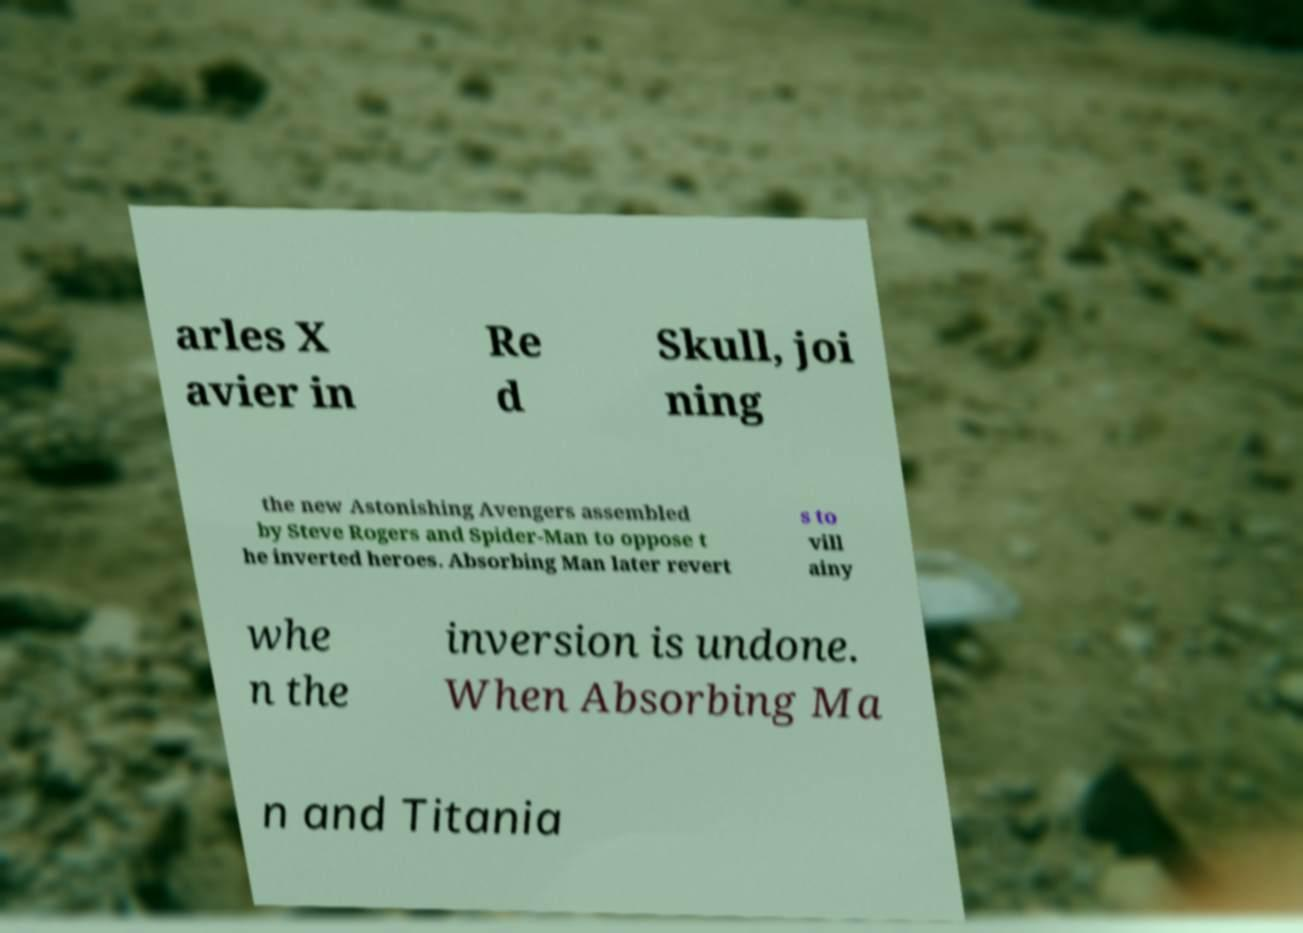Could you assist in decoding the text presented in this image and type it out clearly? arles X avier in Re d Skull, joi ning the new Astonishing Avengers assembled by Steve Rogers and Spider-Man to oppose t he inverted heroes. Absorbing Man later revert s to vill ainy whe n the inversion is undone. When Absorbing Ma n and Titania 